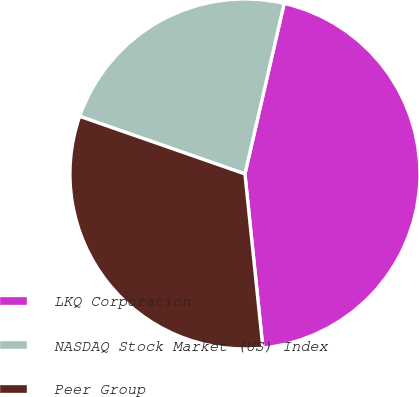Convert chart. <chart><loc_0><loc_0><loc_500><loc_500><pie_chart><fcel>LKQ Corporation<fcel>NASDAQ Stock Market (US) Index<fcel>Peer Group<nl><fcel>44.77%<fcel>23.26%<fcel>31.98%<nl></chart> 